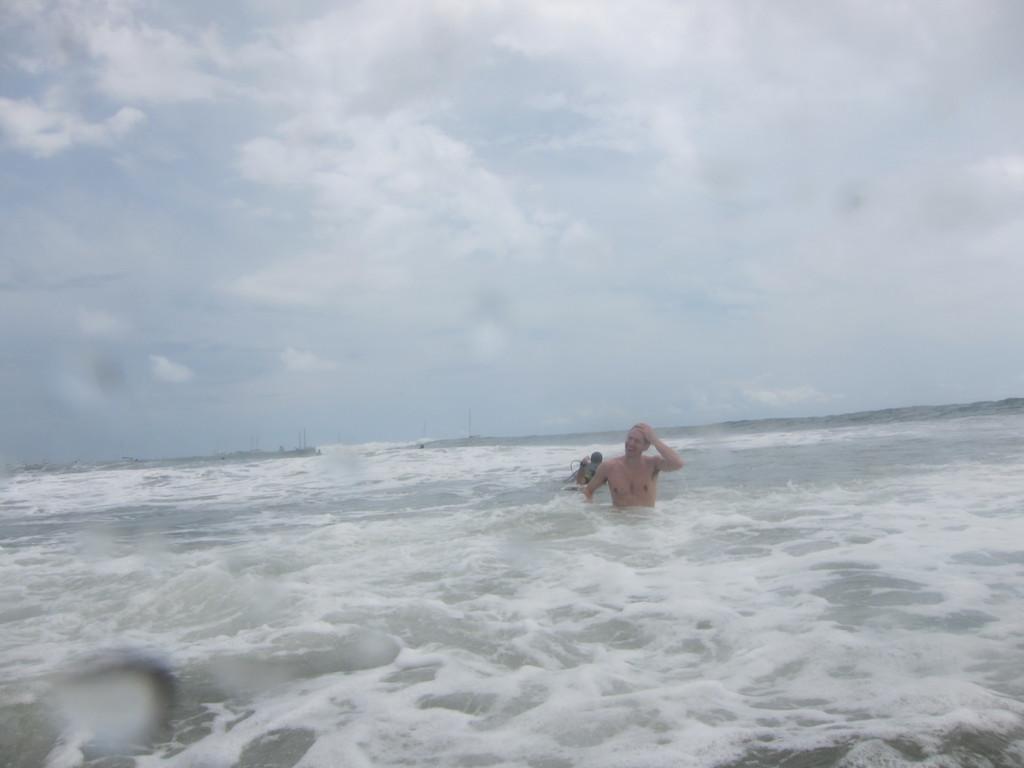Could you give a brief overview of what you see in this image? In this image I can see two persons in the water. And in the background there is sky. 